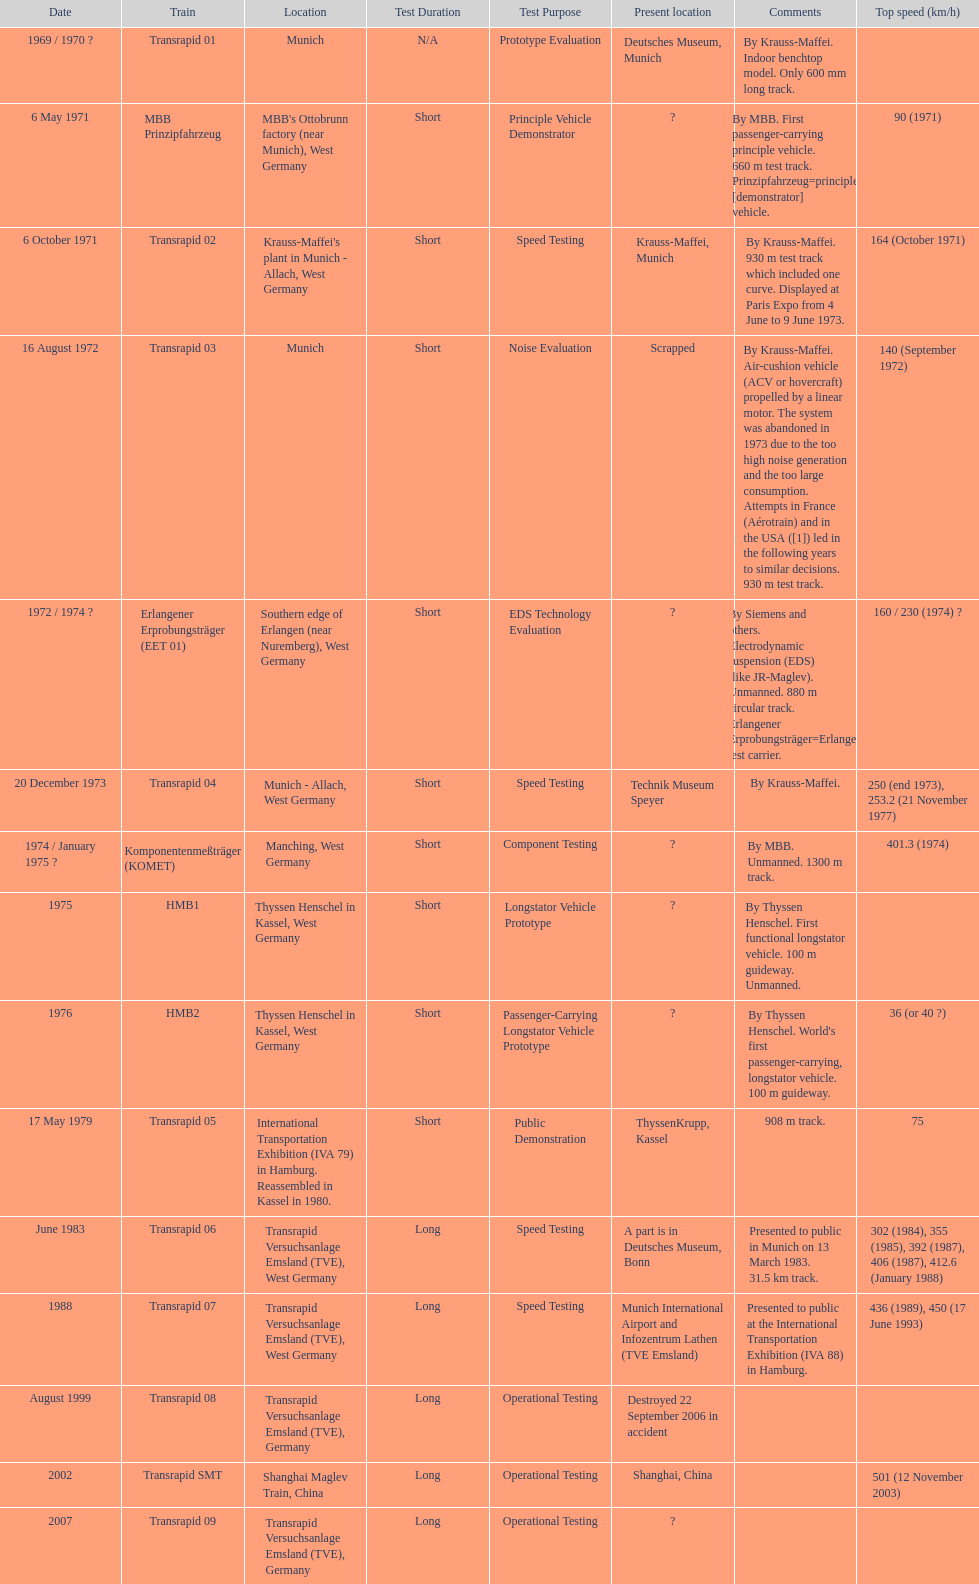What is the number of trains that were either scrapped or destroyed? 2. 